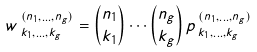<formula> <loc_0><loc_0><loc_500><loc_500>w \, _ { k _ { 1 } , \dots , k _ { g } } ^ { ( n _ { 1 } , \dots , n _ { g } ) } = \binom { n _ { 1 } } { k _ { 1 } } \cdots \binom { n _ { g } } { k _ { g } } \, p \, _ { k _ { 1 } , \dots , k _ { g } } ^ { ( n _ { 1 } , \dots , n _ { g } ) }</formula> 